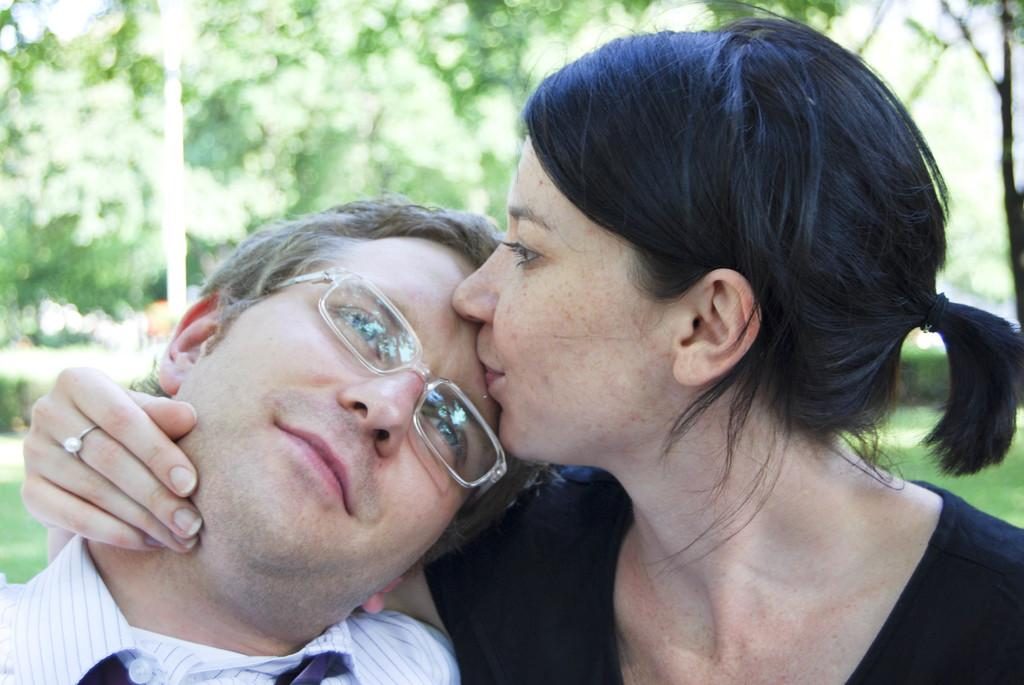How many people are present in the image? There are two people, a man and a woman, present in the image. What can be seen in the background of the image? There are trees in the background of the image. What type of scent can be detected from the woman in the image? There is no information about the scent of the woman in the image, so it cannot be determined. 